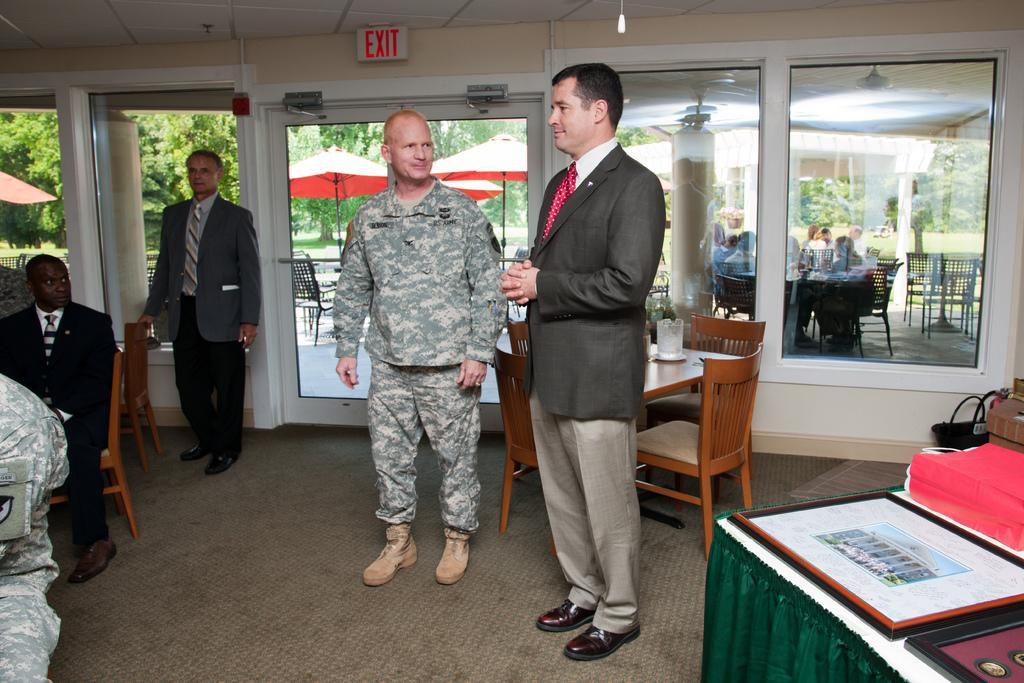How many men are present in the image? There are four men in the image. What are the positions of the men in the image? Three of the men are standing, and one of the men is sitting. What can be seen in the background of the image? There are chairs, tables, people, and trees in the background of the image. What type of toy can be seen in the hands of the sitting man in the image? There is no toy present in the image; the sitting man is not holding anything. What type of rice is being served on the tables in the image? There is no rice present in the image; the tables are not shown to have any food items. 